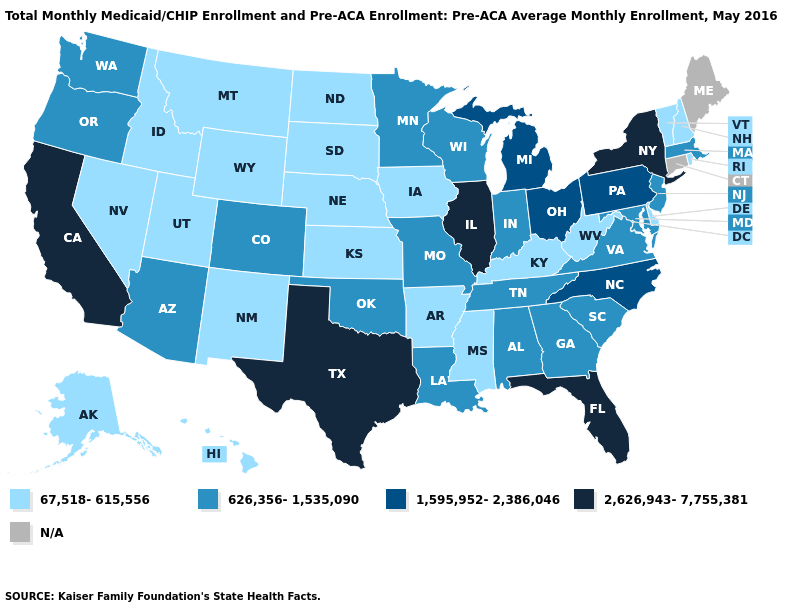What is the value of Michigan?
Give a very brief answer. 1,595,952-2,386,046. What is the lowest value in states that border Delaware?
Give a very brief answer. 626,356-1,535,090. Among the states that border Alabama , which have the highest value?
Quick response, please. Florida. Which states have the lowest value in the MidWest?
Keep it brief. Iowa, Kansas, Nebraska, North Dakota, South Dakota. Name the states that have a value in the range 1,595,952-2,386,046?
Write a very short answer. Michigan, North Carolina, Ohio, Pennsylvania. Among the states that border Wyoming , does Utah have the lowest value?
Give a very brief answer. Yes. Name the states that have a value in the range N/A?
Write a very short answer. Connecticut, Maine. Name the states that have a value in the range 1,595,952-2,386,046?
Keep it brief. Michigan, North Carolina, Ohio, Pennsylvania. What is the value of Montana?
Write a very short answer. 67,518-615,556. Does the map have missing data?
Short answer required. Yes. Name the states that have a value in the range 2,626,943-7,755,381?
Short answer required. California, Florida, Illinois, New York, Texas. Name the states that have a value in the range N/A?
Give a very brief answer. Connecticut, Maine. Name the states that have a value in the range 626,356-1,535,090?
Answer briefly. Alabama, Arizona, Colorado, Georgia, Indiana, Louisiana, Maryland, Massachusetts, Minnesota, Missouri, New Jersey, Oklahoma, Oregon, South Carolina, Tennessee, Virginia, Washington, Wisconsin. 